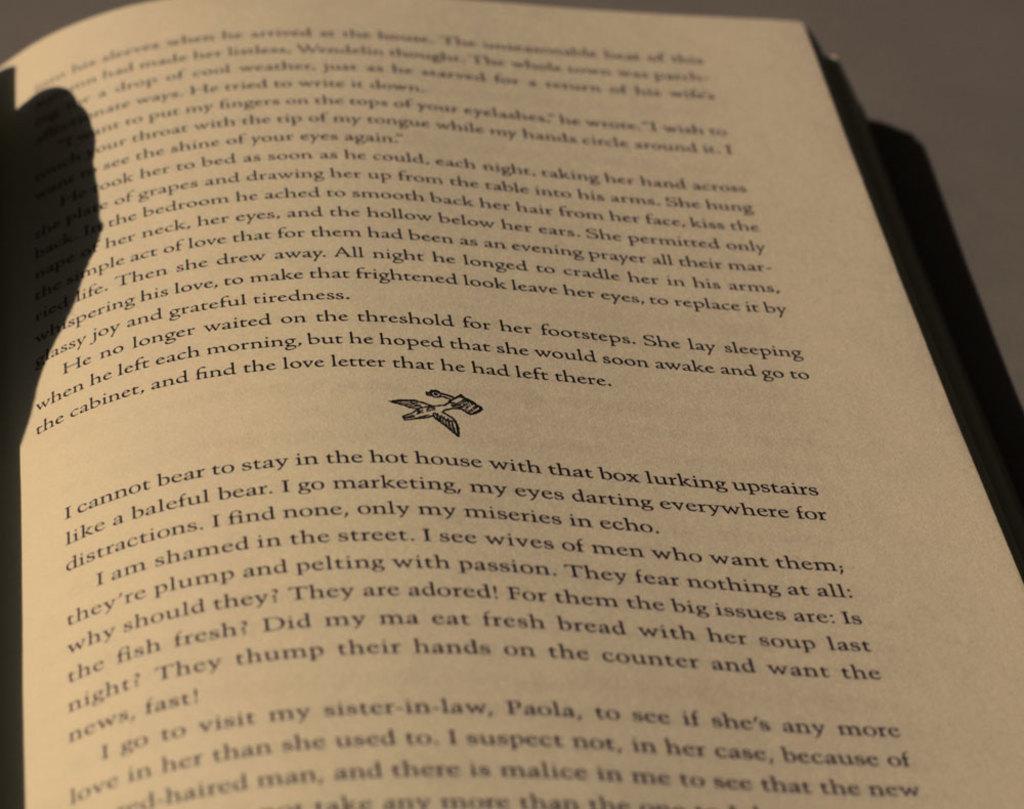What can the narrator not bear to stay in?
Offer a terse response. Hot house. Who is paola?
Offer a terse response. Sister-in-law. 